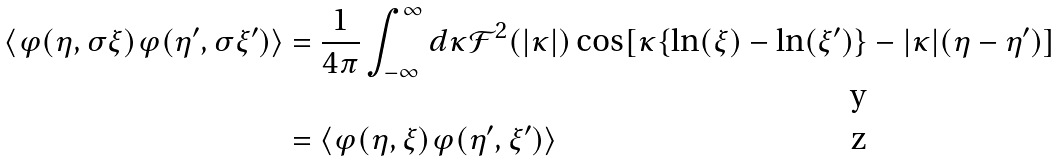Convert formula to latex. <formula><loc_0><loc_0><loc_500><loc_500>\left \langle \varphi ( \eta , \sigma \xi ) \varphi ( \eta ^ { \prime } , \sigma \xi ^ { \prime } ) \right \rangle & = \frac { 1 } { 4 \pi } \int _ { - \infty } ^ { \infty } d \kappa \mathcal { F } ^ { 2 } ( | \kappa | ) \cos [ \kappa \{ \ln ( \xi ) - \ln ( \xi ^ { \prime } ) \} - | \kappa | ( \eta - \eta ^ { \prime } ) ] \\ & = \left \langle \varphi ( \eta , \xi ) \varphi ( \eta ^ { \prime } , \xi ^ { \prime } ) \right \rangle</formula> 